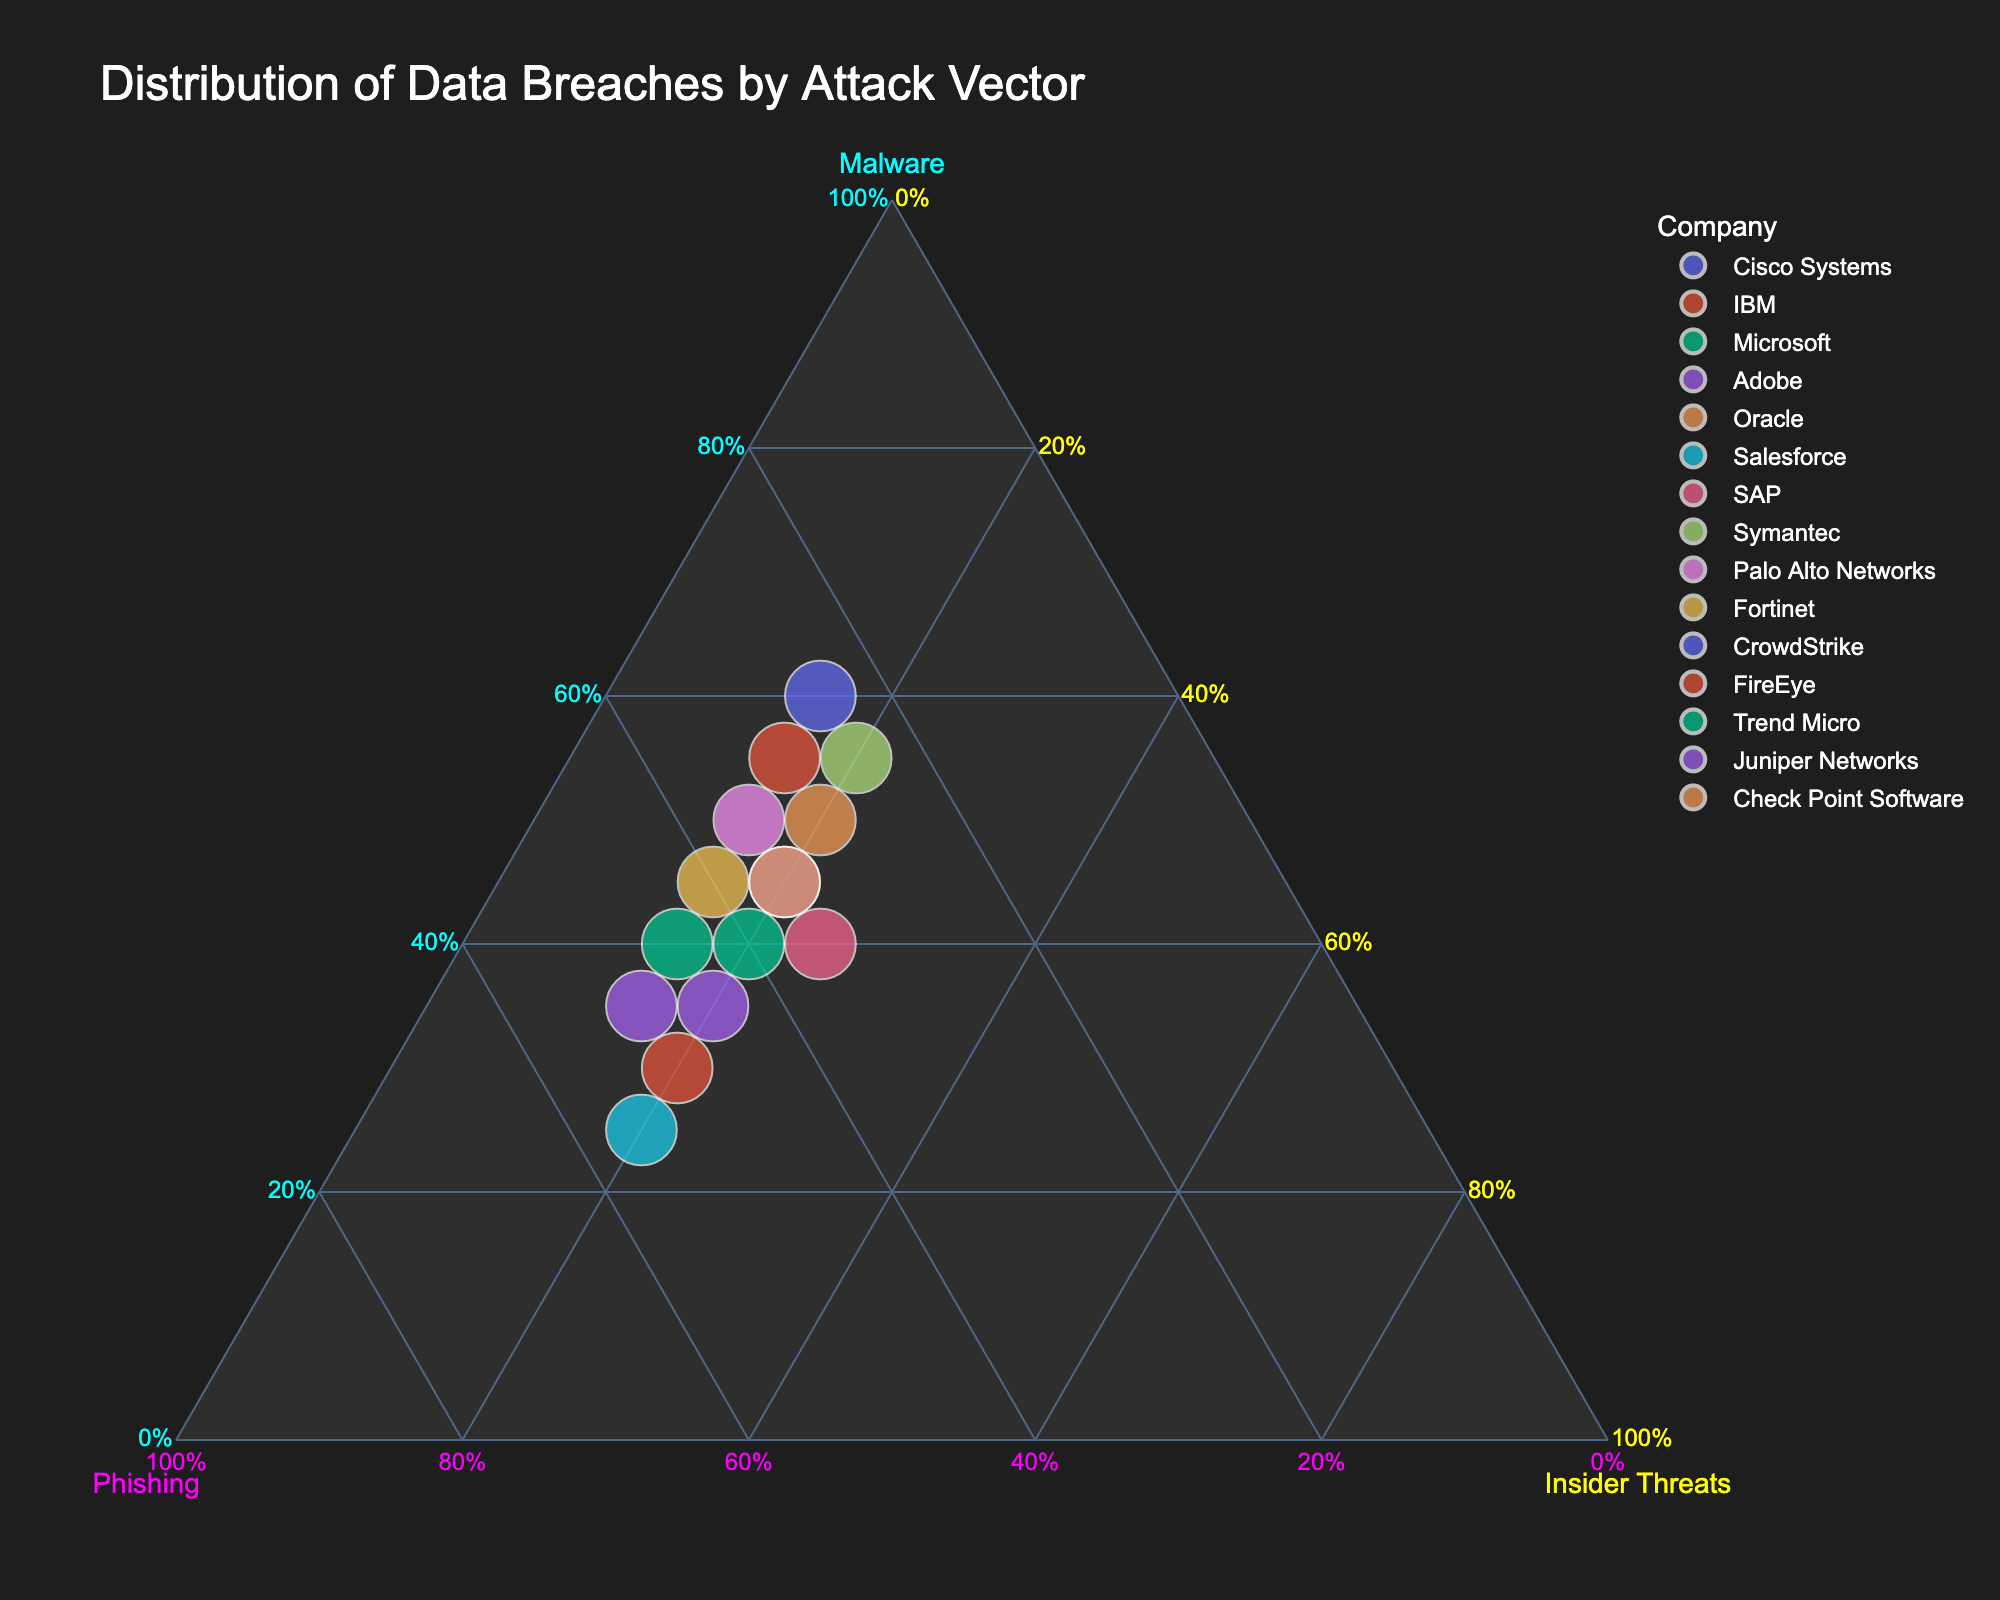What is the title of the plot? The title is typically placed at the top of the plot and it describes its subject. In this plot, it reads "Distribution of Data Breaches by Attack Vector."
Answer: Distribution of Data Breaches by Attack Vector Which company has the highest percentage of data breaches due to malware? By examining the ternary plot, look for the data point that is closest to the “Malware” axis. In this plot, this point represents CrowdStrike.
Answer: CrowdStrike Which two companies have equal percentages of insider threats? On a ternary plot, points with the same positioning concerning the "Insider Threats" axis will have equal percentages. Here, all companies Converge towards 20% and 15% for insider threats, but significant pairs are Microsoft and Check Point Software.
Answer: Microsoft and Check Point Software Which company has the largest total number of data breaches? The size of the data point on the ternary plot indicates the total number of breaches. The largest data point belongs to Cisco Systems.
Answer: Cisco Systems What is the percentage of phishing-related breaches for Salesforce? Locate the point for Salesforce and look at its positioning related to the “Phishing” axis. Salesforce is positioned closer to the Phishing axis, reflecting approximately 55%.
Answer: 55% Between Oracle and Adobe, which company has a higher proportion of malware-related breaches? Compare their respective positions along the "Malware" axis. Oracle is positioned closer to the "Malware" side than Adobe.
Answer: Oracle How many companies report breaches equally from malware, phishing, and insider threats? On a ternary plot, such a data point would lie at the central third of the plot. No point lies in this central intersection, showing no such balance among the companies.
Answer: None What is the total number of breaches for Trend Micro? You need to check the size of the data point representing Trend Micro. This figure-sized calculation is demonstrated by the size depiction, which shows this value.
Answer: Total number not visual, need detailed data What trend is observed regarding the insider threats among the companies? Examine the distribution of the points relative to the "Insider Threats" axis. Most companies' points lie in two vertical clusters, indicating around 20% and 15% insider threats involvement across the dataset.
Answer: Consistency around 20% and 15% 